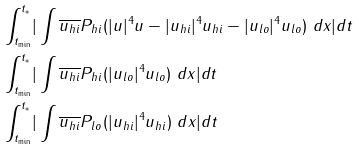Convert formula to latex. <formula><loc_0><loc_0><loc_500><loc_500>\int _ { t _ { \min } } ^ { t _ { * } } & | \int \overline { u _ { h i } } P _ { h i } ( | u | ^ { 4 } u - | u _ { h i } | ^ { 4 } u _ { h i } - | u _ { l o } | ^ { 4 } u _ { l o } ) \ d x | d t \\ \int _ { t _ { \min } } ^ { t _ { * } } & | \int \overline { u _ { h i } } P _ { h i } ( | u _ { l o } | ^ { 4 } u _ { l o } ) \ d x | d t \\ \int _ { t _ { \min } } ^ { t _ { * } } & | \int \overline { u _ { h i } } P _ { l o } ( | u _ { h i } | ^ { 4 } u _ { h i } ) \ d x | d t</formula> 